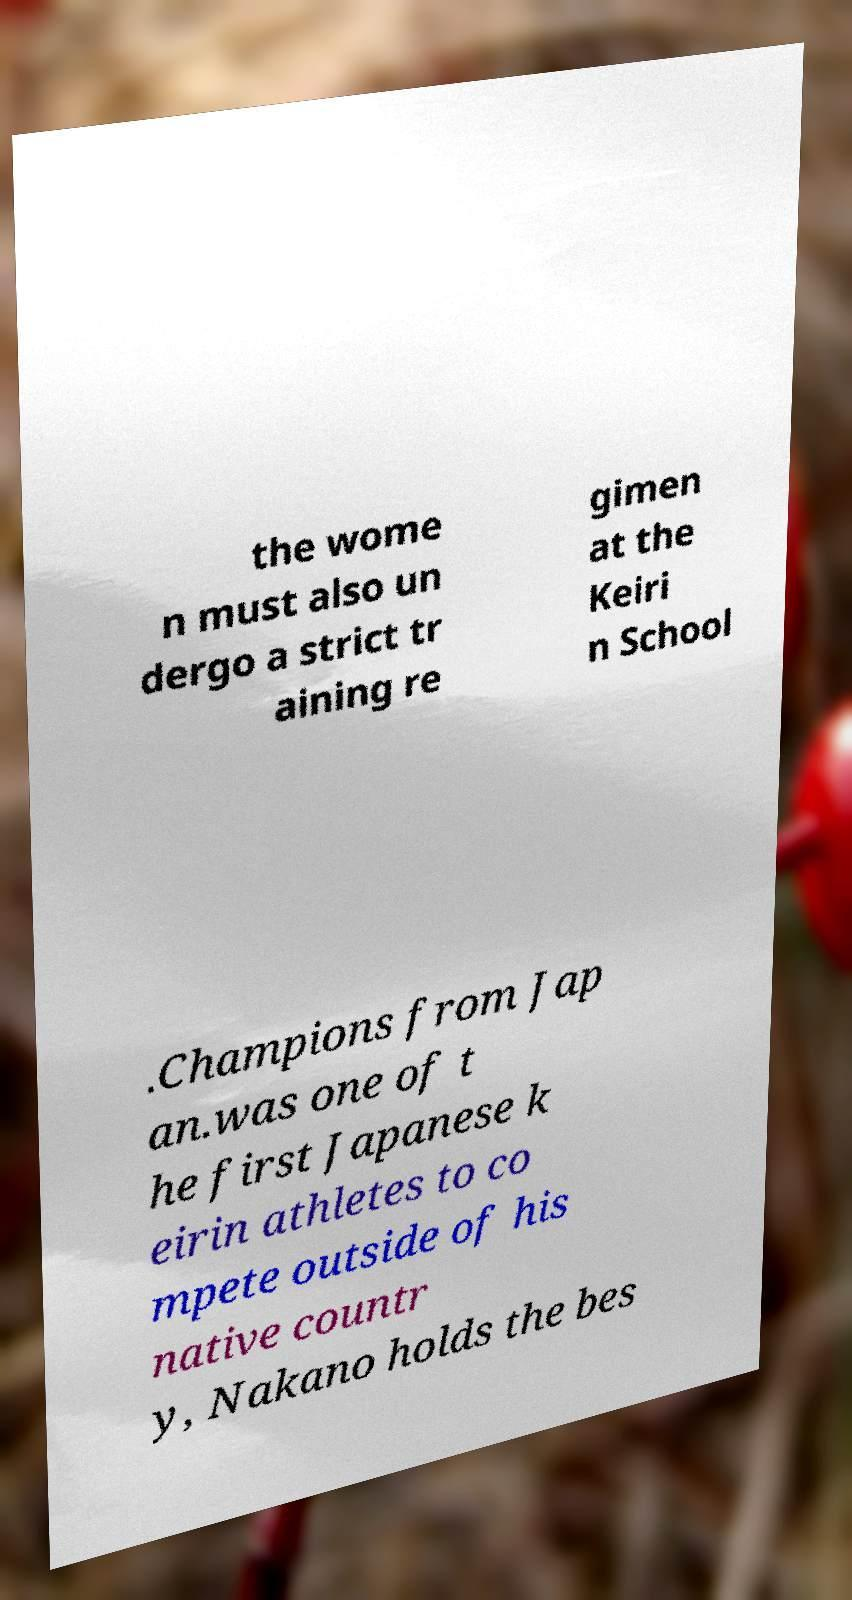Please read and relay the text visible in this image. What does it say? the wome n must also un dergo a strict tr aining re gimen at the Keiri n School .Champions from Jap an.was one of t he first Japanese k eirin athletes to co mpete outside of his native countr y, Nakano holds the bes 